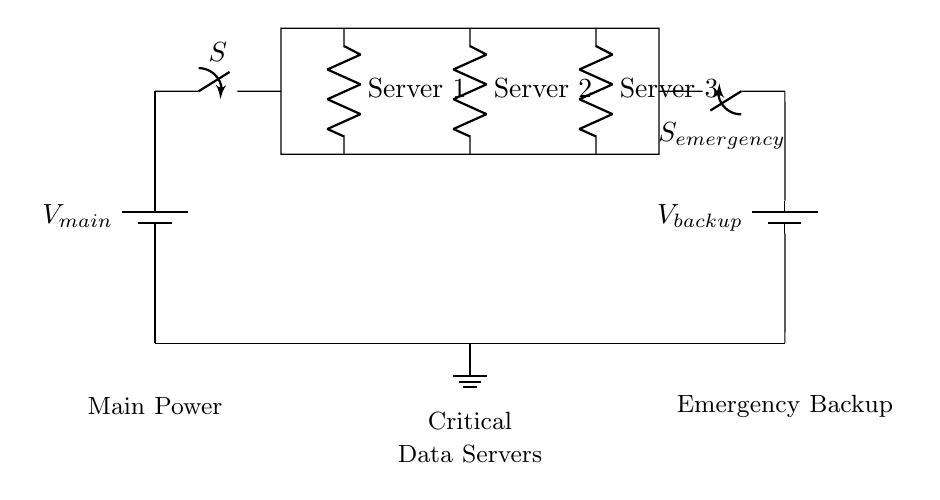What is the main voltage source in the circuit? The main voltage source is represented by the battery labeled V_main. It supplies power to the entire circuit.
Answer: V_main How many server loads are present in the circuit? The circuit has three server loads shown as resistors labeled Server 1, Server 2, and Server 3. These represent the critical data servers connected in parallel.
Answer: 3 What happens when the emergency switch is closed? Closing the emergency switch (labeled S_emergency) connects the backup battery (V_backup) to the server loads, providing an alternative power source if the main power supply fails.
Answer: Backup power supplied What is the significance of having parallel connections for the server loads? The parallel configuration allows each server to operate independently, meaning if one server fails, the others continue to receive power, ensuring reliability and uptime for critical systems.
Answer: Independent operation Which component disconnects the main power supply? The switch labeled S is the component that can disconnect the main power supply from the circuit, allowing for maintenance or in case of failure.
Answer: Switch S What is the role of the ground in this circuit? The ground provides a reference point for the circuit voltages and serves as a return path for the current, ensuring safety and stability in the circuit operation.
Answer: Reference point 